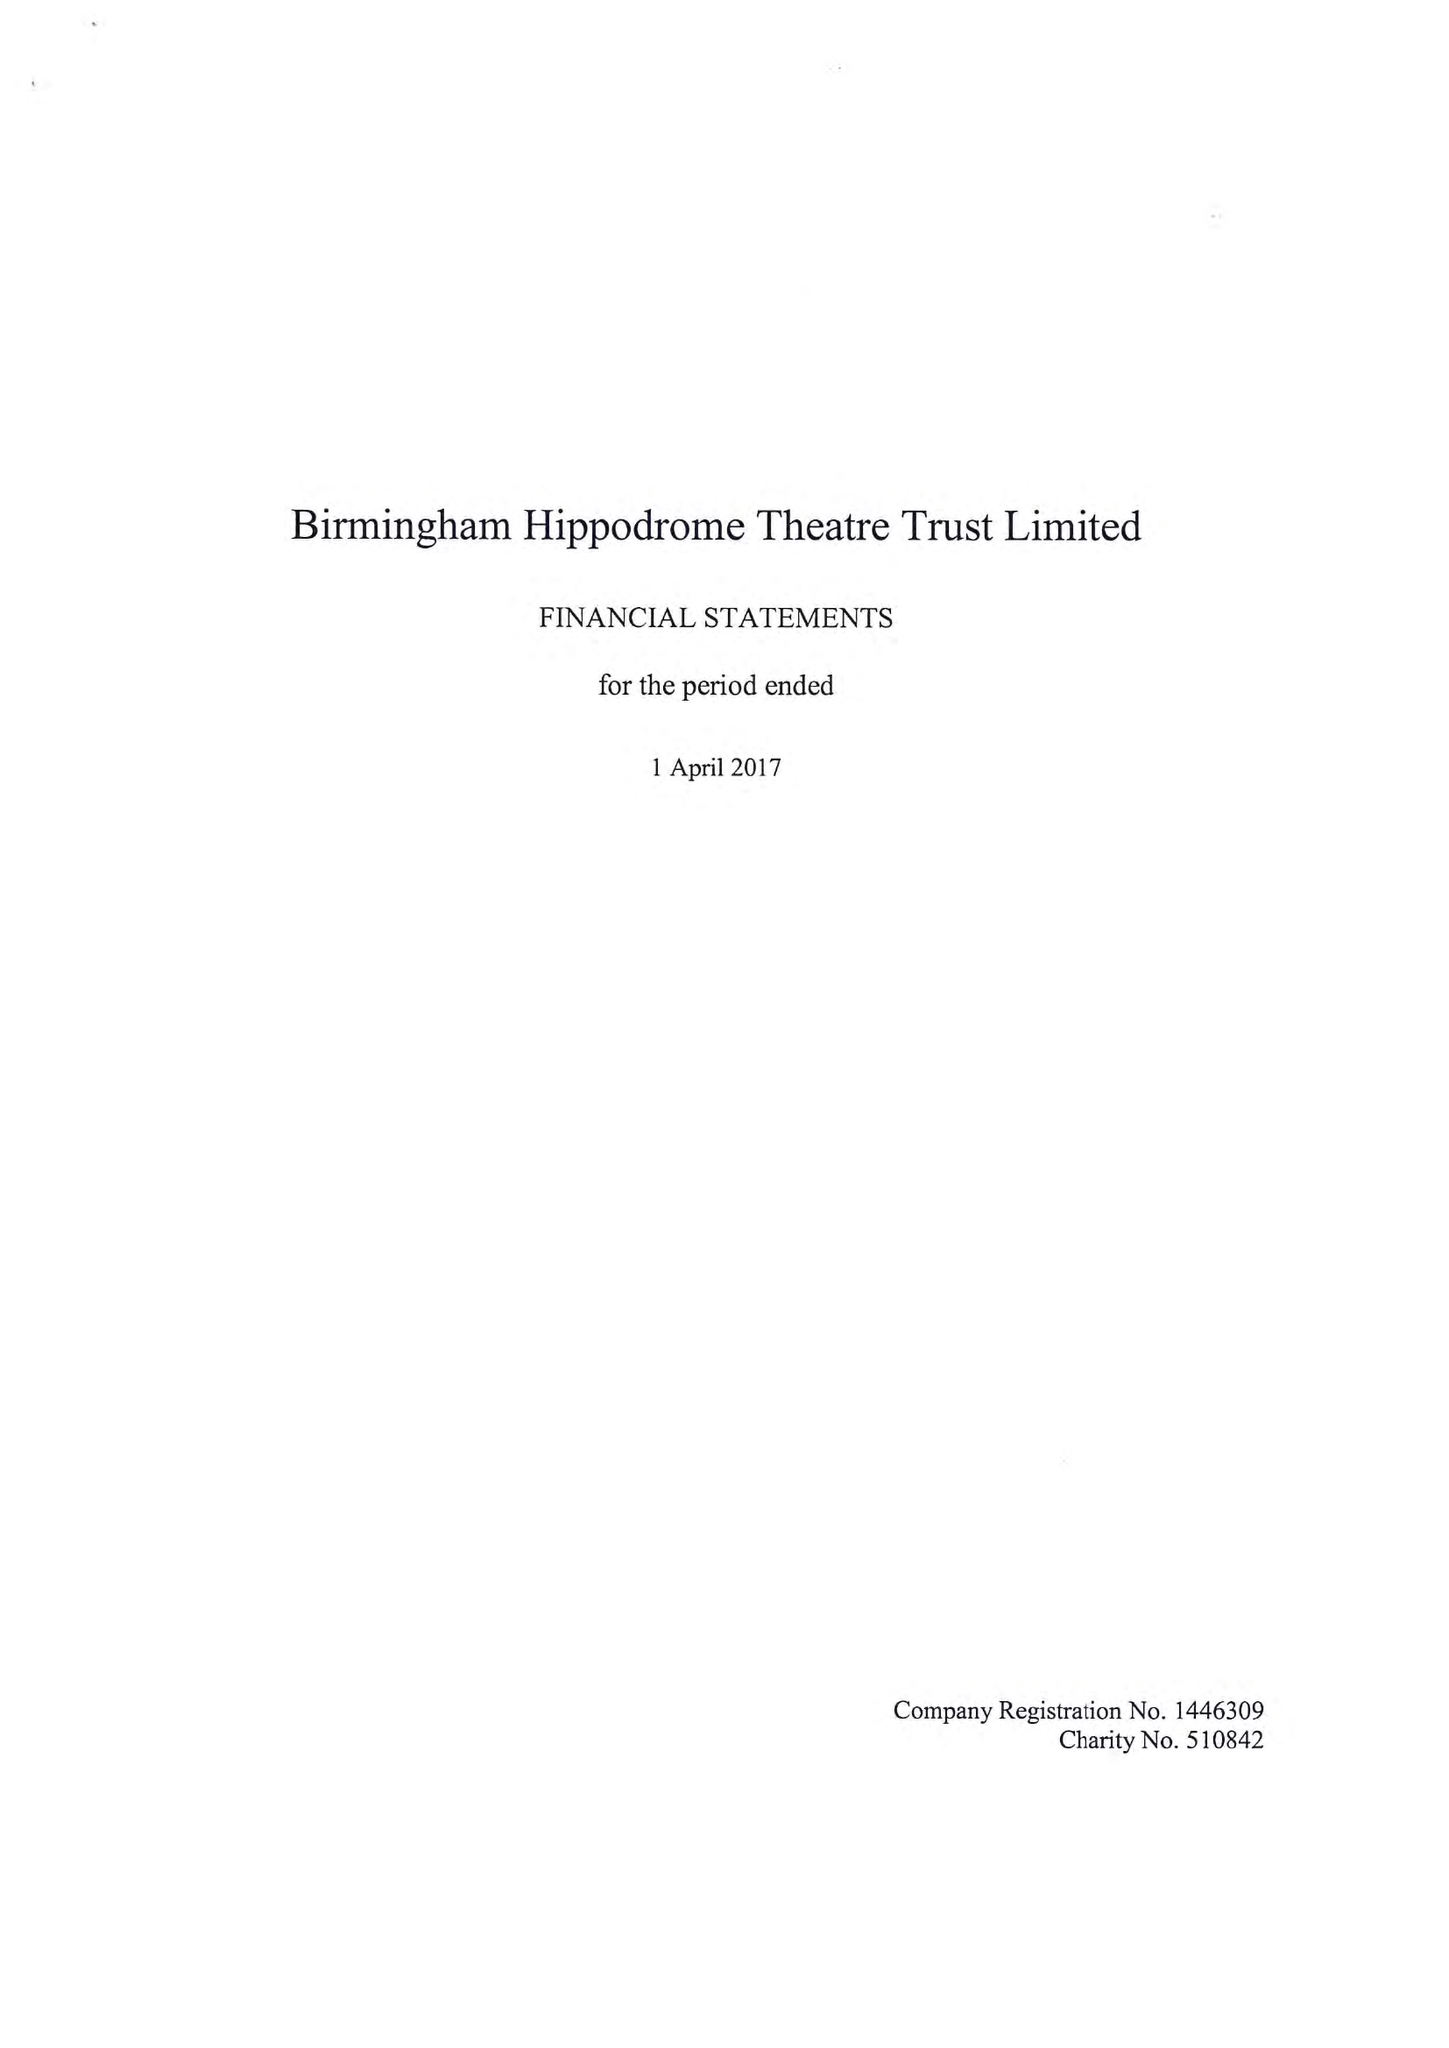What is the value for the address__street_line?
Answer the question using a single word or phrase. HURST STREET 